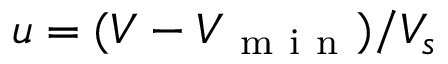Convert formula to latex. <formula><loc_0><loc_0><loc_500><loc_500>u = ( V - V _ { m i n } ) / V _ { s }</formula> 